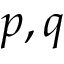Convert formula to latex. <formula><loc_0><loc_0><loc_500><loc_500>p , q</formula> 